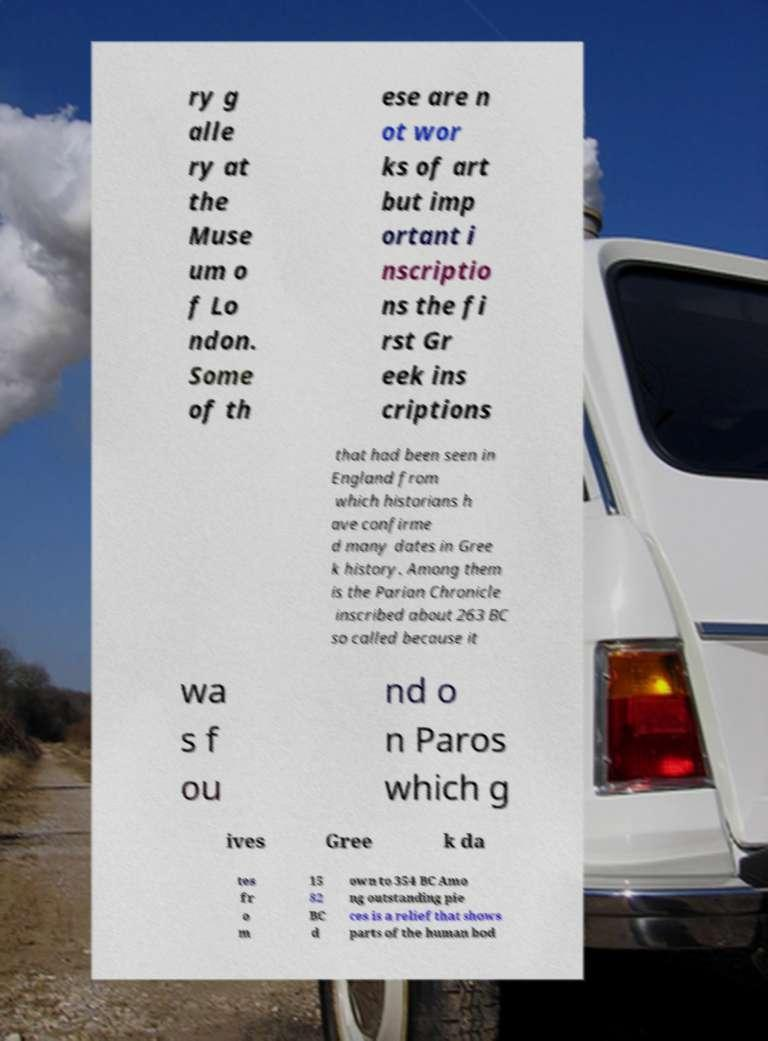Could you assist in decoding the text presented in this image and type it out clearly? ry g alle ry at the Muse um o f Lo ndon. Some of th ese are n ot wor ks of art but imp ortant i nscriptio ns the fi rst Gr eek ins criptions that had been seen in England from which historians h ave confirme d many dates in Gree k history. Among them is the Parian Chronicle inscribed about 263 BC so called because it wa s f ou nd o n Paros which g ives Gree k da tes fr o m 15 82 BC d own to 354 BC Amo ng outstanding pie ces is a relief that shows parts of the human bod 